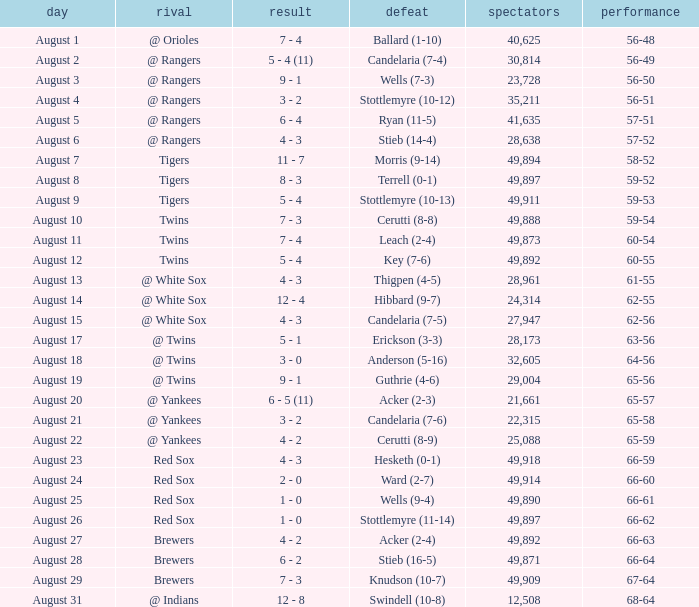What was the Attendance high on August 28? 49871.0. 